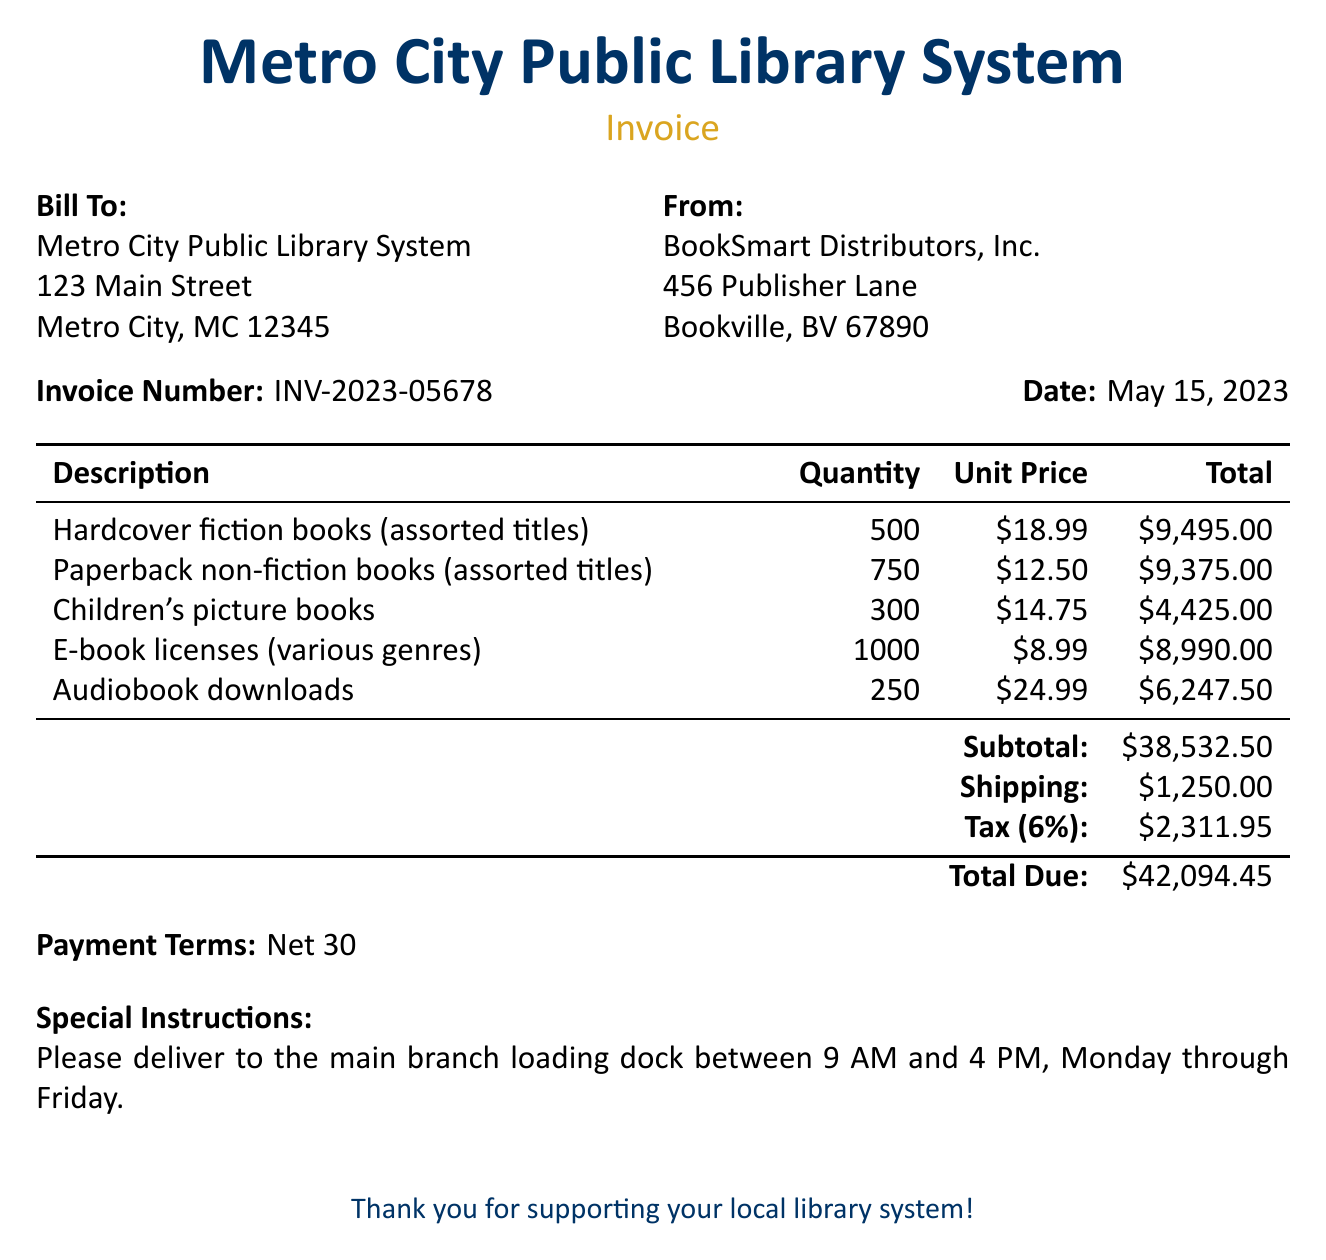What is the invoice number? The invoice number is a unique identifier for this billing document, specified near the top.
Answer: INV-2023-05678 What is the date of the invoice? The date is noted next to the invoice number, indicating when the invoice was issued.
Answer: May 15, 2023 Who is the supplier of the books? The supplier's name is provided in the "From" section, indicating who the invoice is from.
Answer: BookSmart Distributors, Inc What is the subtotal amount? The subtotal is the sum of all items before shipping and tax, listed at the bottom of the item table.
Answer: $38,532.50 How many hardcover fiction books were ordered? The quantity of hardcover fiction books is specified in the itemized list of the invoice.
Answer: 500 What is the shipping cost? The shipping cost is listed in the lower section of the invoice among the financial details.
Answer: $1,250.00 What is the total due amount? This amount includes all costs—subtotal, shipping, and tax—indicated at the end of the invoice.
Answer: $42,094.45 What percentage is the tax applied? The tax percentage is stated directly in the tax line of the invoice, indicating the rate at which tax is calculated.
Answer: 6% What are the payment terms? The payment terms are provided to inform the recipient about the time frame for payment.
Answer: Net 30 What special instructions are included? The special instructions specify delivery guidelines, indicating when and where items should be delivered.
Answer: Please deliver to the main branch loading dock between 9 AM and 4 PM, Monday through Friday 